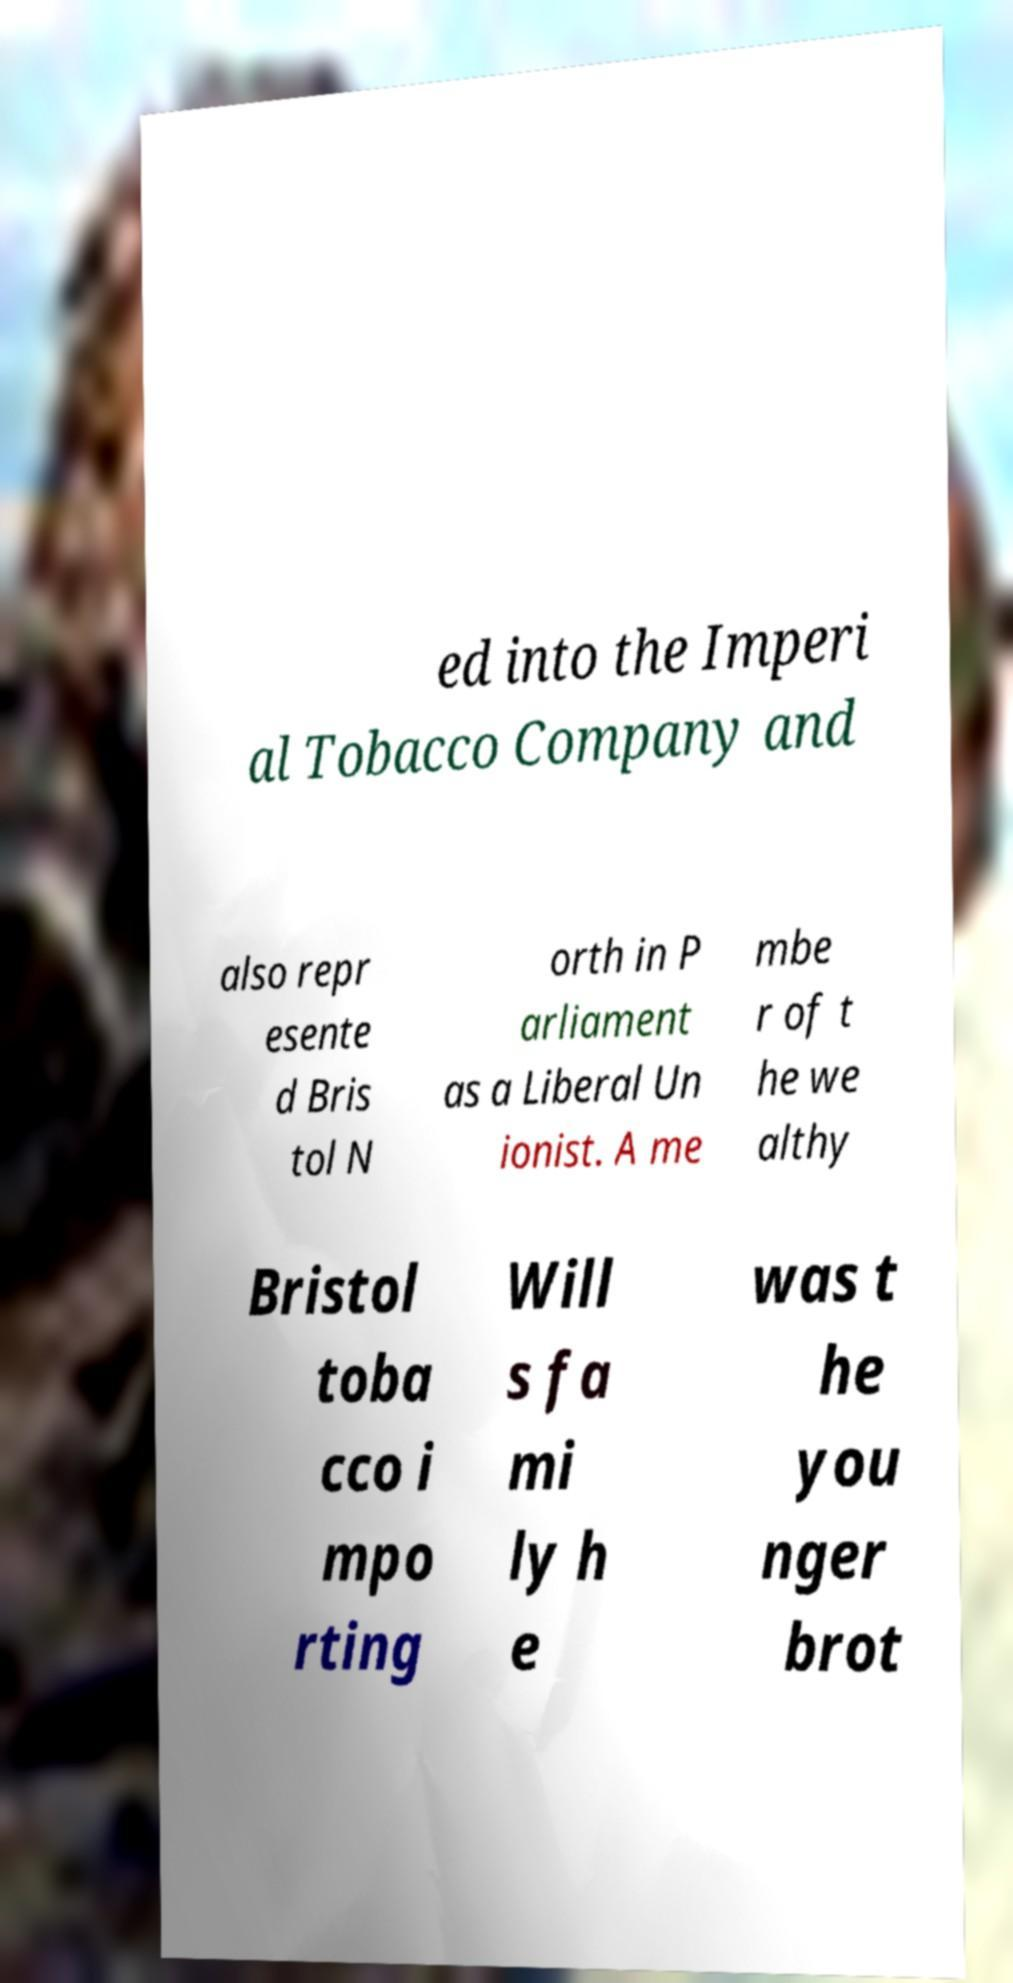I need the written content from this picture converted into text. Can you do that? ed into the Imperi al Tobacco Company and also repr esente d Bris tol N orth in P arliament as a Liberal Un ionist. A me mbe r of t he we althy Bristol toba cco i mpo rting Will s fa mi ly h e was t he you nger brot 